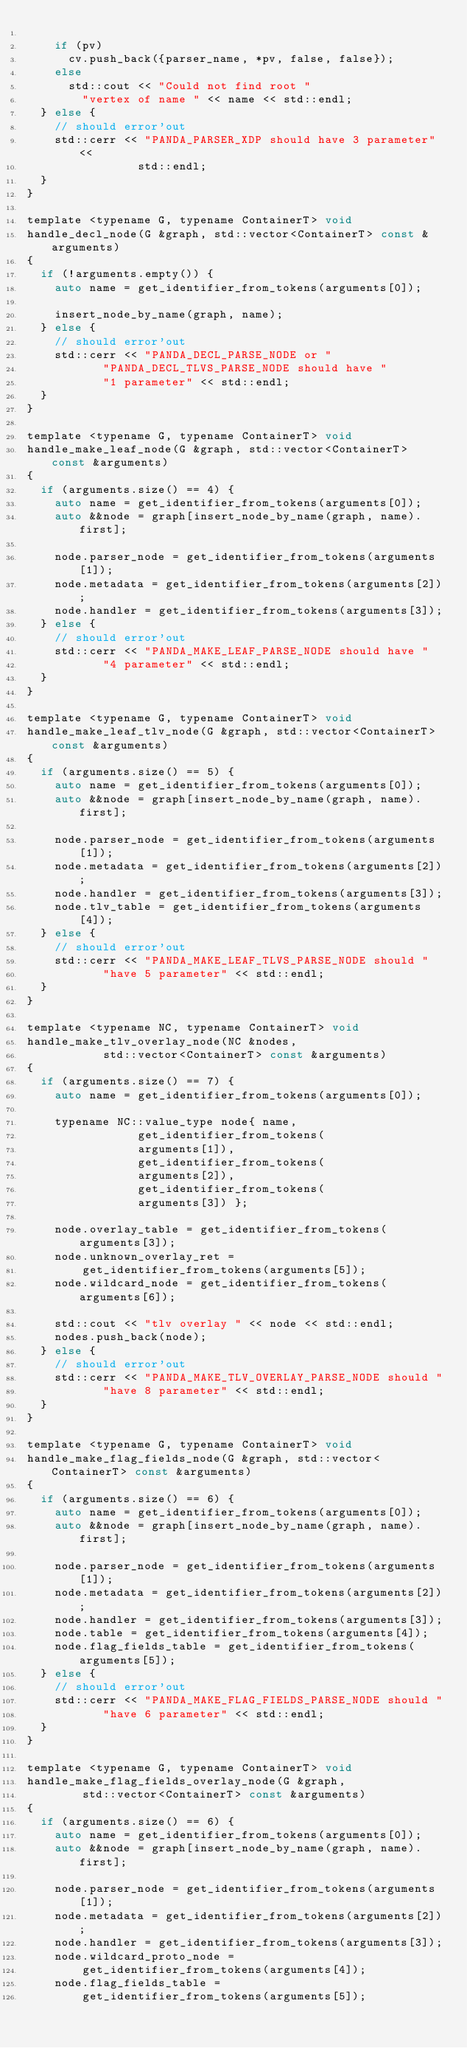Convert code to text. <code><loc_0><loc_0><loc_500><loc_500><_C_>
		if (pv)
			cv.push_back({parser_name, *pv, false, false});
		else
			std::cout << "Could not find root "
				"vertex of name " << name << std::endl;
	} else {
		// should error'out
		std::cerr << "PANDA_PARSER_XDP should have 3 parameter" <<
								std::endl;
	}
}

template <typename G, typename ContainerT> void
handle_decl_node(G &graph, std::vector<ContainerT> const &arguments)
{
	if (!arguments.empty()) {
		auto name = get_identifier_from_tokens(arguments[0]);

		insert_node_by_name(graph, name);
	} else {
		// should error'out
		std::cerr << "PANDA_DECL_PARSE_NODE or "
			     "PANDA_DECL_TLVS_PARSE_NODE should have "
			     "1 parameter" << std::endl;
	}
}

template <typename G, typename ContainerT> void
handle_make_leaf_node(G &graph, std::vector<ContainerT> const &arguments)
{
	if (arguments.size() == 4) {
		auto name = get_identifier_from_tokens(arguments[0]);
		auto &&node = graph[insert_node_by_name(graph, name).first];

		node.parser_node = get_identifier_from_tokens(arguments[1]);
		node.metadata = get_identifier_from_tokens(arguments[2]);
		node.handler = get_identifier_from_tokens(arguments[3]);
	} else {
		// should error'out
		std::cerr << "PANDA_MAKE_LEAF_PARSE_NODE should have "
			     "4 parameter" << std::endl;
	}
}

template <typename G, typename ContainerT> void
handle_make_leaf_tlv_node(G &graph, std::vector<ContainerT> const &arguments)
{
	if (arguments.size() == 5) {
		auto name = get_identifier_from_tokens(arguments[0]);
		auto &&node = graph[insert_node_by_name(graph, name).first];

		node.parser_node = get_identifier_from_tokens(arguments[1]);
		node.metadata = get_identifier_from_tokens(arguments[2]);
		node.handler = get_identifier_from_tokens(arguments[3]);
		node.tlv_table = get_identifier_from_tokens(arguments[4]);
	} else {
		// should error'out
		std::cerr << "PANDA_MAKE_LEAF_TLVS_PARSE_NODE should "
			     "have 5 parameter" << std::endl;
	}
}

template <typename NC, typename ContainerT> void
handle_make_tlv_overlay_node(NC &nodes,
			     std::vector<ContainerT> const &arguments)
{
	if (arguments.size() == 7) {
		auto name = get_identifier_from_tokens(arguments[0]);

		typename NC::value_type node{ name,
					      get_identifier_from_tokens(
								arguments[1]),
					      get_identifier_from_tokens(
								arguments[2]),
					      get_identifier_from_tokens(
								arguments[3]) };

		node.overlay_table = get_identifier_from_tokens(arguments[3]);
		node.unknown_overlay_ret =
				get_identifier_from_tokens(arguments[5]);
		node.wildcard_node = get_identifier_from_tokens(arguments[6]);

		std::cout << "tlv overlay " << node << std::endl;
		nodes.push_back(node);
	} else {
		// should error'out
		std::cerr << "PANDA_MAKE_TLV_OVERLAY_PARSE_NODE should "
			     "have 8 parameter" << std::endl;
	}
}

template <typename G, typename ContainerT> void
handle_make_flag_fields_node(G &graph, std::vector<ContainerT> const &arguments)
{
	if (arguments.size() == 6) {
		auto name = get_identifier_from_tokens(arguments[0]);
		auto &&node = graph[insert_node_by_name(graph, name).first];

		node.parser_node = get_identifier_from_tokens(arguments[1]);
		node.metadata = get_identifier_from_tokens(arguments[2]);
		node.handler = get_identifier_from_tokens(arguments[3]);
		node.table = get_identifier_from_tokens(arguments[4]);
		node.flag_fields_table = get_identifier_from_tokens(arguments[5]);
	} else {
		// should error'out
		std::cerr << "PANDA_MAKE_FLAG_FIELDS_PARSE_NODE should "
			     "have 6 parameter" << std::endl;
	}
}

template <typename G, typename ContainerT> void
handle_make_flag_fields_overlay_node(G &graph,
				std::vector<ContainerT> const &arguments)
{
	if (arguments.size() == 6) {
		auto name = get_identifier_from_tokens(arguments[0]);
		auto &&node = graph[insert_node_by_name(graph, name).first];

		node.parser_node = get_identifier_from_tokens(arguments[1]);
		node.metadata = get_identifier_from_tokens(arguments[2]);
		node.handler = get_identifier_from_tokens(arguments[3]);
		node.wildcard_proto_node =
				get_identifier_from_tokens(arguments[4]);
		node.flag_fields_table =
				get_identifier_from_tokens(arguments[5]);</code> 